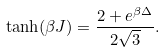<formula> <loc_0><loc_0><loc_500><loc_500>\tanh ( \beta J ) = \frac { 2 + e ^ { \beta \Delta } } { 2 \sqrt { 3 } } .</formula> 